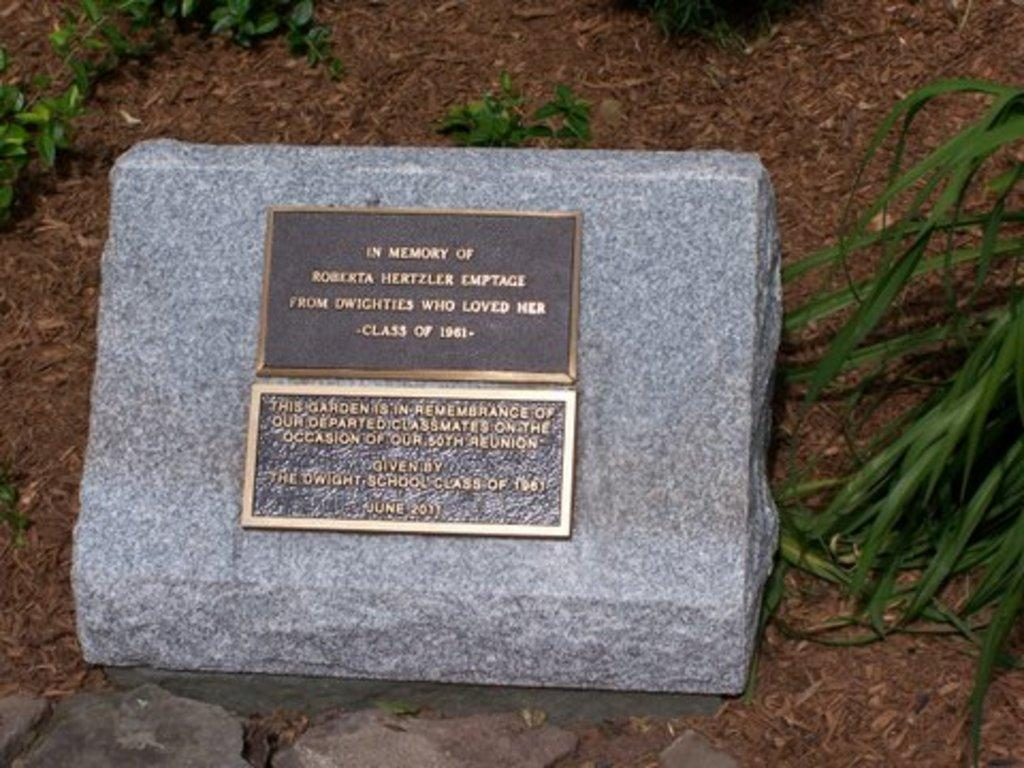What is the main object in the image? There is a headstone in the image. Are there any other elements present in the image besides the headstone? Yes, there are plants in the image. What type of hand can be seen holding an insect near the headstone in the image? There is no hand or insect present in the image; it only features a headstone and plants. 